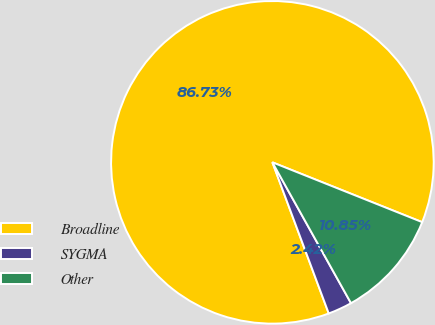<chart> <loc_0><loc_0><loc_500><loc_500><pie_chart><fcel>Broadline<fcel>SYGMA<fcel>Other<nl><fcel>86.73%<fcel>2.42%<fcel>10.85%<nl></chart> 